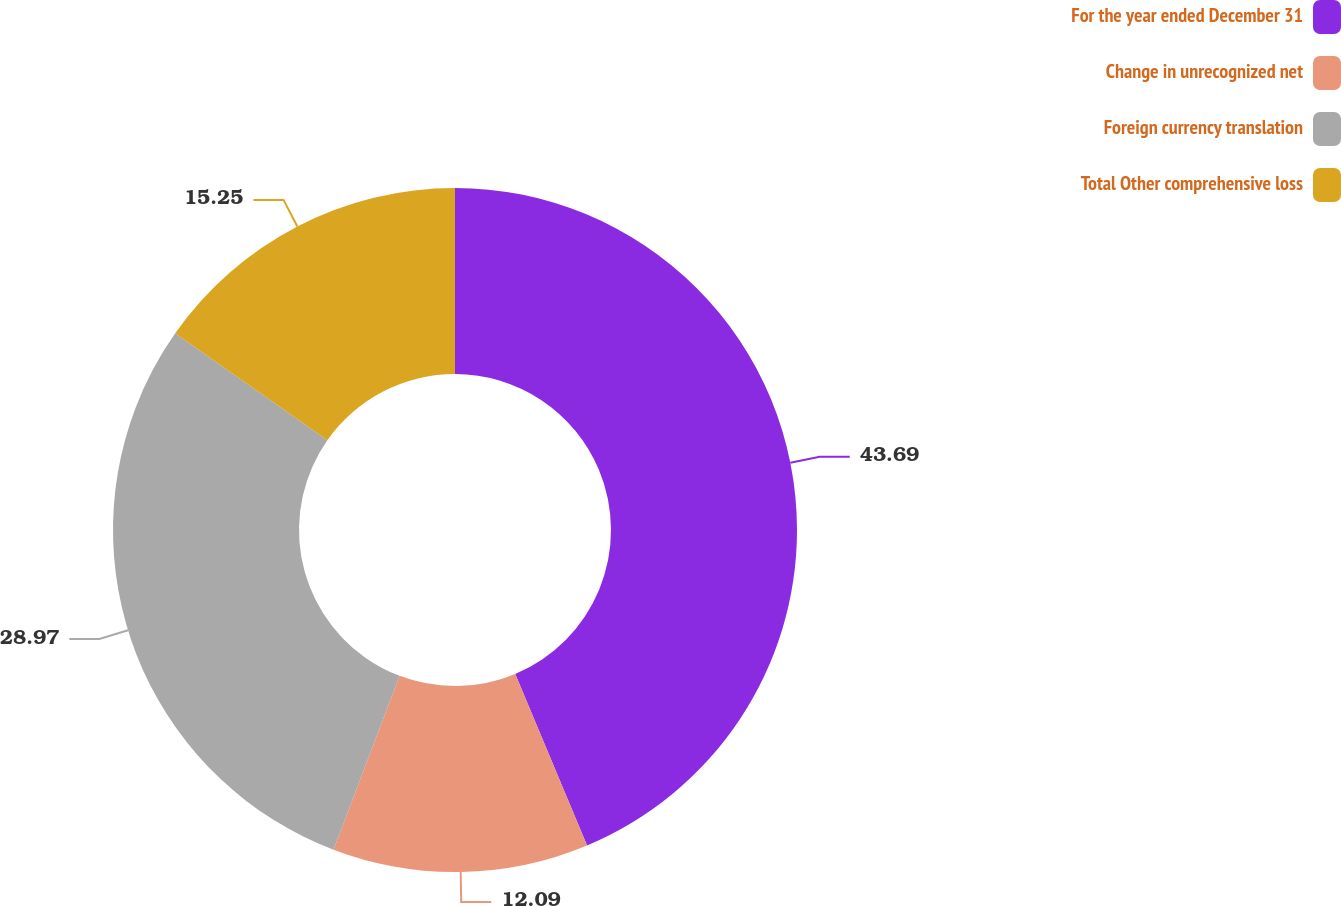Convert chart to OTSL. <chart><loc_0><loc_0><loc_500><loc_500><pie_chart><fcel>For the year ended December 31<fcel>Change in unrecognized net<fcel>Foreign currency translation<fcel>Total Other comprehensive loss<nl><fcel>43.69%<fcel>12.09%<fcel>28.97%<fcel>15.25%<nl></chart> 